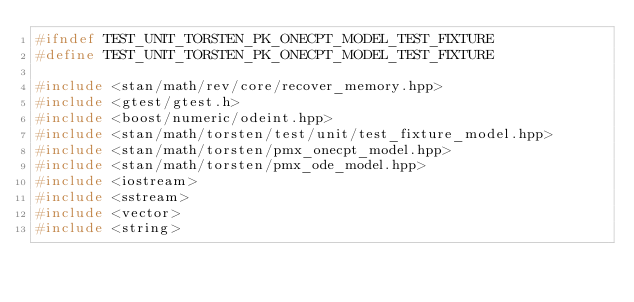Convert code to text. <code><loc_0><loc_0><loc_500><loc_500><_C++_>#ifndef TEST_UNIT_TORSTEN_PK_ONECPT_MODEL_TEST_FIXTURE
#define TEST_UNIT_TORSTEN_PK_ONECPT_MODEL_TEST_FIXTURE

#include <stan/math/rev/core/recover_memory.hpp>
#include <gtest/gtest.h>
#include <boost/numeric/odeint.hpp>
#include <stan/math/torsten/test/unit/test_fixture_model.hpp>
#include <stan/math/torsten/pmx_onecpt_model.hpp>
#include <stan/math/torsten/pmx_ode_model.hpp>
#include <iostream>
#include <sstream>
#include <vector>
#include <string>
</code> 